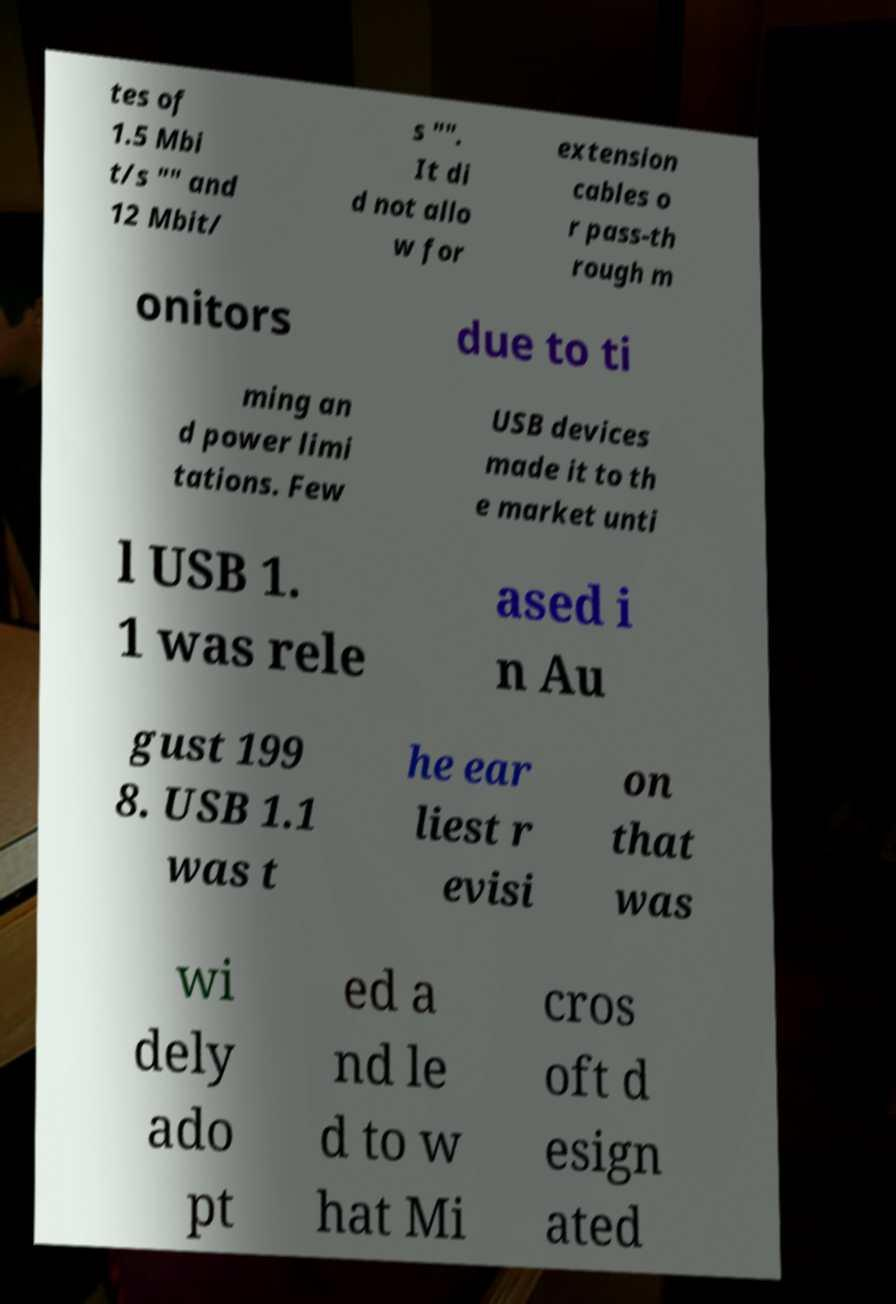I need the written content from this picture converted into text. Can you do that? tes of 1.5 Mbi t/s "" and 12 Mbit/ s "". It di d not allo w for extension cables o r pass-th rough m onitors due to ti ming an d power limi tations. Few USB devices made it to th e market unti l USB 1. 1 was rele ased i n Au gust 199 8. USB 1.1 was t he ear liest r evisi on that was wi dely ado pt ed a nd le d to w hat Mi cros oft d esign ated 